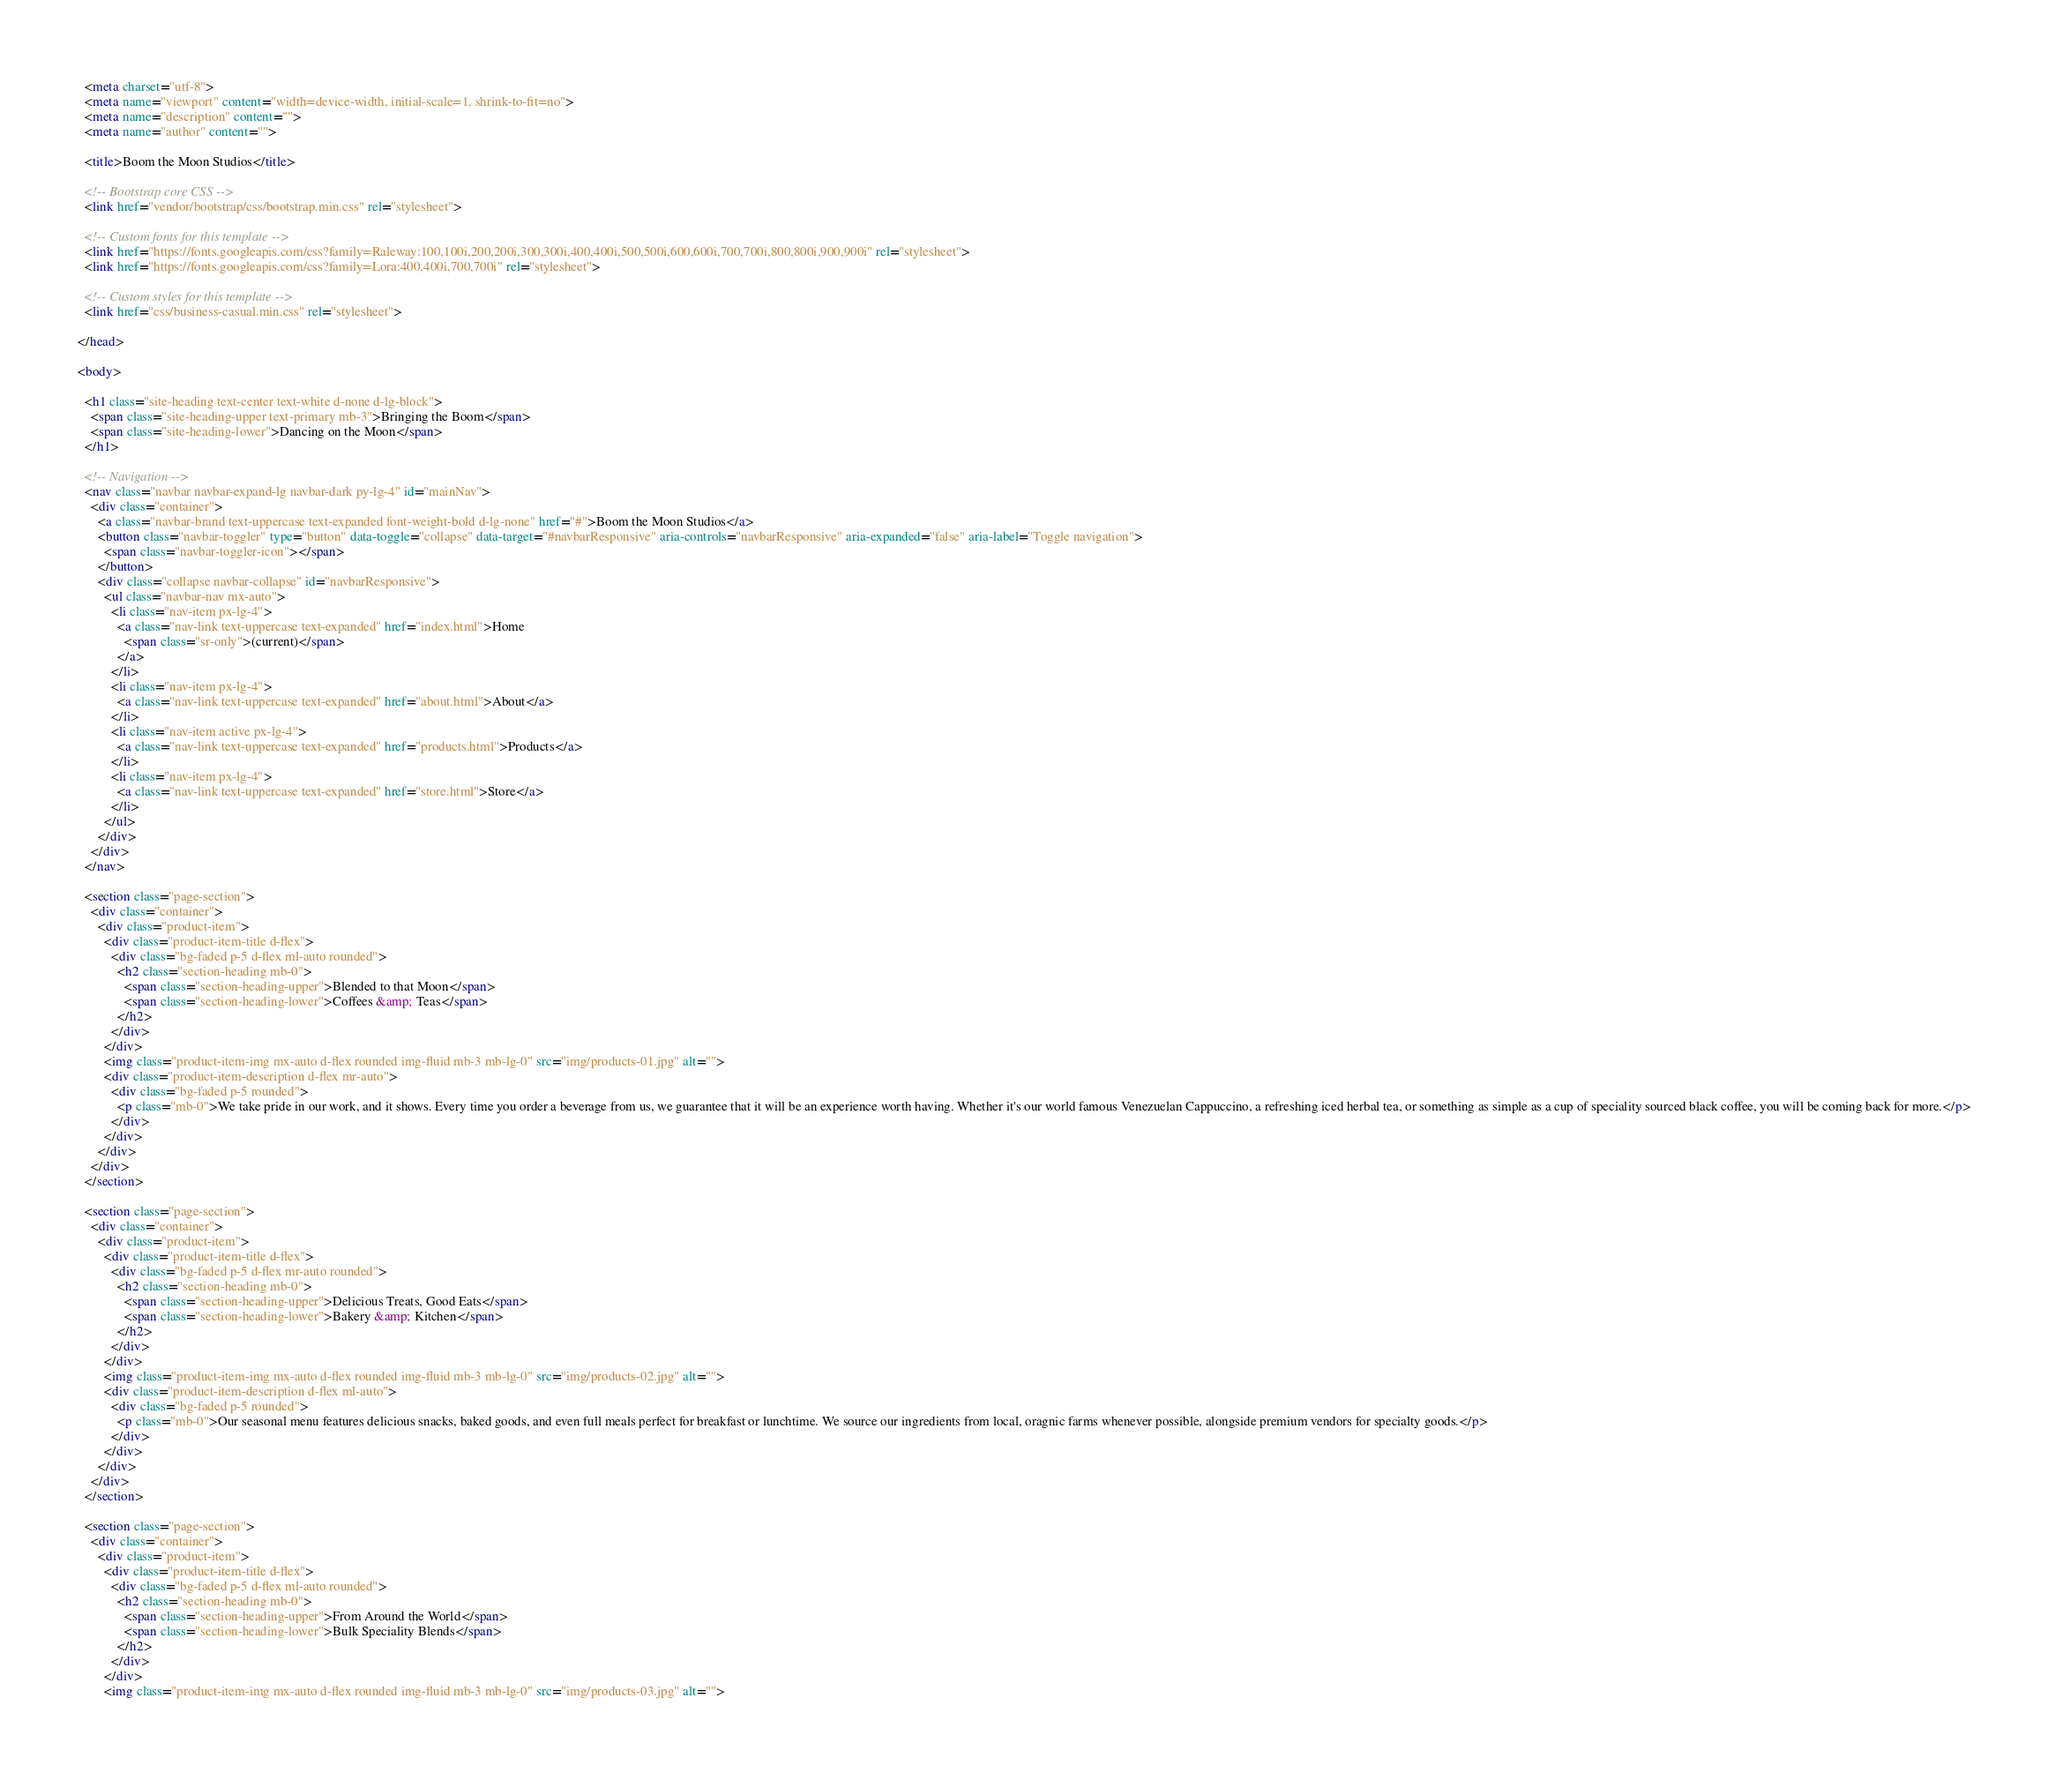<code> <loc_0><loc_0><loc_500><loc_500><_HTML_>
  <meta charset="utf-8">
  <meta name="viewport" content="width=device-width, initial-scale=1, shrink-to-fit=no">
  <meta name="description" content="">
  <meta name="author" content="">

  <title>Boom the Moon Studios</title>

  <!-- Bootstrap core CSS -->
  <link href="vendor/bootstrap/css/bootstrap.min.css" rel="stylesheet">

  <!-- Custom fonts for this template -->
  <link href="https://fonts.googleapis.com/css?family=Raleway:100,100i,200,200i,300,300i,400,400i,500,500i,600,600i,700,700i,800,800i,900,900i" rel="stylesheet">
  <link href="https://fonts.googleapis.com/css?family=Lora:400,400i,700,700i" rel="stylesheet">

  <!-- Custom styles for this template -->
  <link href="css/business-casual.min.css" rel="stylesheet">

</head>

<body>

  <h1 class="site-heading text-center text-white d-none d-lg-block">
    <span class="site-heading-upper text-primary mb-3">Bringing the Boom</span>
    <span class="site-heading-lower">Dancing on the Moon</span>
  </h1>

  <!-- Navigation -->
  <nav class="navbar navbar-expand-lg navbar-dark py-lg-4" id="mainNav">
    <div class="container">
      <a class="navbar-brand text-uppercase text-expanded font-weight-bold d-lg-none" href="#">Boom the Moon Studios</a>
      <button class="navbar-toggler" type="button" data-toggle="collapse" data-target="#navbarResponsive" aria-controls="navbarResponsive" aria-expanded="false" aria-label="Toggle navigation">
        <span class="navbar-toggler-icon"></span>
      </button>
      <div class="collapse navbar-collapse" id="navbarResponsive">
        <ul class="navbar-nav mx-auto">
          <li class="nav-item px-lg-4">
            <a class="nav-link text-uppercase text-expanded" href="index.html">Home
              <span class="sr-only">(current)</span>
            </a>
          </li>
          <li class="nav-item px-lg-4">
            <a class="nav-link text-uppercase text-expanded" href="about.html">About</a>
          </li>
          <li class="nav-item active px-lg-4">
            <a class="nav-link text-uppercase text-expanded" href="products.html">Products</a>
          </li>
          <li class="nav-item px-lg-4">
            <a class="nav-link text-uppercase text-expanded" href="store.html">Store</a>
          </li>
        </ul>
      </div>
    </div>
  </nav>

  <section class="page-section">
    <div class="container">
      <div class="product-item">
        <div class="product-item-title d-flex">
          <div class="bg-faded p-5 d-flex ml-auto rounded">
            <h2 class="section-heading mb-0">
              <span class="section-heading-upper">Blended to that Moon</span>
              <span class="section-heading-lower">Coffees &amp; Teas</span>
            </h2>
          </div>
        </div>
        <img class="product-item-img mx-auto d-flex rounded img-fluid mb-3 mb-lg-0" src="img/products-01.jpg" alt="">
        <div class="product-item-description d-flex mr-auto">
          <div class="bg-faded p-5 rounded">
            <p class="mb-0">We take pride in our work, and it shows. Every time you order a beverage from us, we guarantee that it will be an experience worth having. Whether it's our world famous Venezuelan Cappuccino, a refreshing iced herbal tea, or something as simple as a cup of speciality sourced black coffee, you will be coming back for more.</p>
          </div>
        </div>
      </div>
    </div>
  </section>

  <section class="page-section">
    <div class="container">
      <div class="product-item">
        <div class="product-item-title d-flex">
          <div class="bg-faded p-5 d-flex mr-auto rounded">
            <h2 class="section-heading mb-0">
              <span class="section-heading-upper">Delicious Treats, Good Eats</span>
              <span class="section-heading-lower">Bakery &amp; Kitchen</span>
            </h2>
          </div>
        </div>
        <img class="product-item-img mx-auto d-flex rounded img-fluid mb-3 mb-lg-0" src="img/products-02.jpg" alt="">
        <div class="product-item-description d-flex ml-auto">
          <div class="bg-faded p-5 rounded">
            <p class="mb-0">Our seasonal menu features delicious snacks, baked goods, and even full meals perfect for breakfast or lunchtime. We source our ingredients from local, oragnic farms whenever possible, alongside premium vendors for specialty goods.</p>
          </div>
        </div>
      </div>
    </div>
  </section>

  <section class="page-section">
    <div class="container">
      <div class="product-item">
        <div class="product-item-title d-flex">
          <div class="bg-faded p-5 d-flex ml-auto rounded">
            <h2 class="section-heading mb-0">
              <span class="section-heading-upper">From Around the World</span>
              <span class="section-heading-lower">Bulk Speciality Blends</span>
            </h2>
          </div>
        </div>
        <img class="product-item-img mx-auto d-flex rounded img-fluid mb-3 mb-lg-0" src="img/products-03.jpg" alt=""></code> 